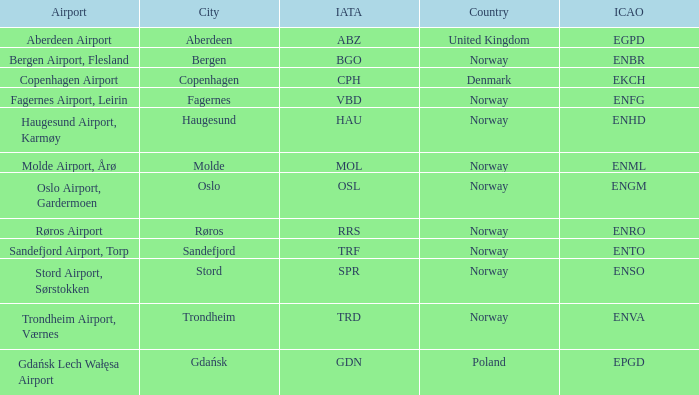What Country has a ICAO of EKCH? Denmark. 